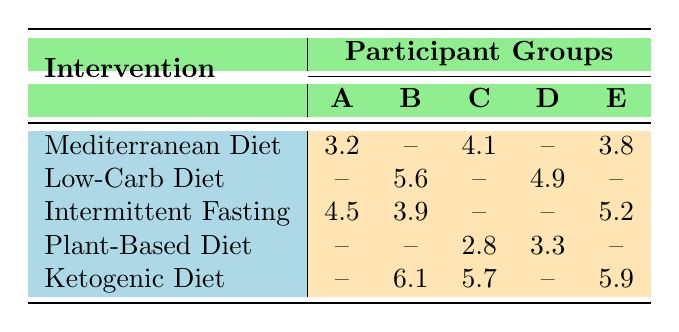What is the weight loss outcome for Group B on the Low-Carb Diet? The table shows that Group B had a weight loss outcome of 5.6 kg on the Low-Carb Diet.
Answer: 5.6 kg Which participant group lost the most weight on the Intermittent Fasting plan? According to the table, Group E lost 5.2 kg, which is more than any other group on the Intermittent Fasting plan (Group A lost 4.5 kg and Group B lost 3.9 kg).
Answer: Group E Did Group C participate in the Ketogenic Diet? The table indicates that there is a weight loss value listed for Group C under the Ketogenic Diet, which shows that they did participate.
Answer: Yes What is the total weight loss from the Mediterranean Diet across all participant groups? Summing the weight loss outcomes: Group A (3.2 kg) + Group C (4.1 kg) + Group E (3.8 kg) gives a total of 11.1 kg. Groups B and D did not report a weight loss for this diet.
Answer: 11.1 kg Which diet resulted in the highest weight loss for Group E? The table shows that Group E lost 5.9 kg on the Ketogenic Diet, which is higher than other diets they participated in (3.8 kg on the Mediterranean and 5.2 kg on Intermittent Fasting).
Answer: Ketogenic Diet How does the average weight loss of Group A compare to Group D's average? Group A lost 3.2 kg on the Mediterranean Diet and 4.5 kg on Intermittent Fasting, averaging (3.2 + 4.5) / 2 = 3.85 kg. Group D lost 4.9 kg on Low-Carb and 3.3 kg on Plant-Based, averaging (4.9 + 3.3) / 2 = 4.1 kg. Group D has a higher average weight loss.
Answer: Group D's average is higher What was the weight loss difference between the highest and lowest group weights for the Plant-Based Diet? Group C lost 2.8 kg and Group D lost 3.3 kg, resulting in a difference of 3.3 kg - 2.8 kg = 0.5 kg.
Answer: 0.5 kg Which intervention resulted in the lowest weight loss for Group C? The lowest weight loss for Group C in the table is 2.8 kg for the Plant-Based Diet, while they lost higher amounts on both Mediterranean (4.1 kg) and Ketogenic (5.7 kg).
Answer: Plant-Based Diet If we consider Group B's performance, what was their best diet for weight loss and by how much did they outperform the other diets they participated in? Group B lost the most weight on the Ketogenic Diet with 6.1 kg. In comparison to the Low-Carb Diet (5.6 kg) and Intermittent Fasting (3.9 kg), the difference between the best and the second best is 6.1 kg - 5.6 kg = 0.5 kg.
Answer: Ketogenic Diet, outperforming by 0.5 kg 